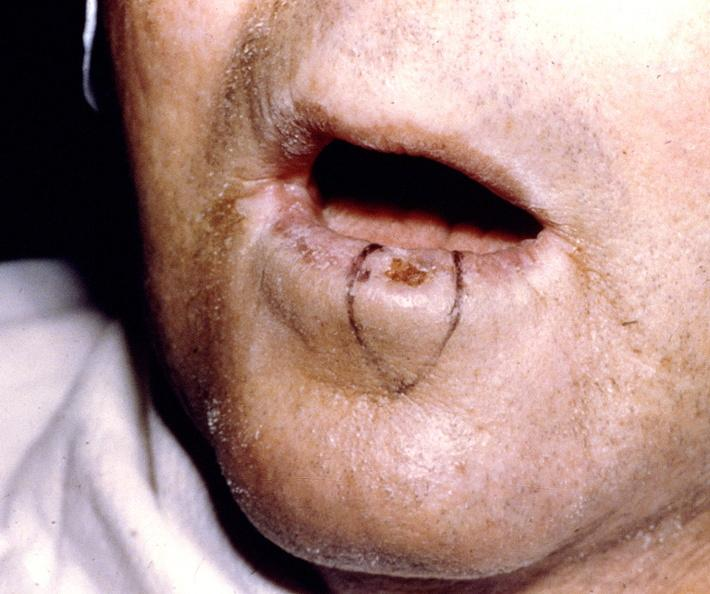does immunostain for growth hormone show squamous cell carcinoma, lip?
Answer the question using a single word or phrase. No 